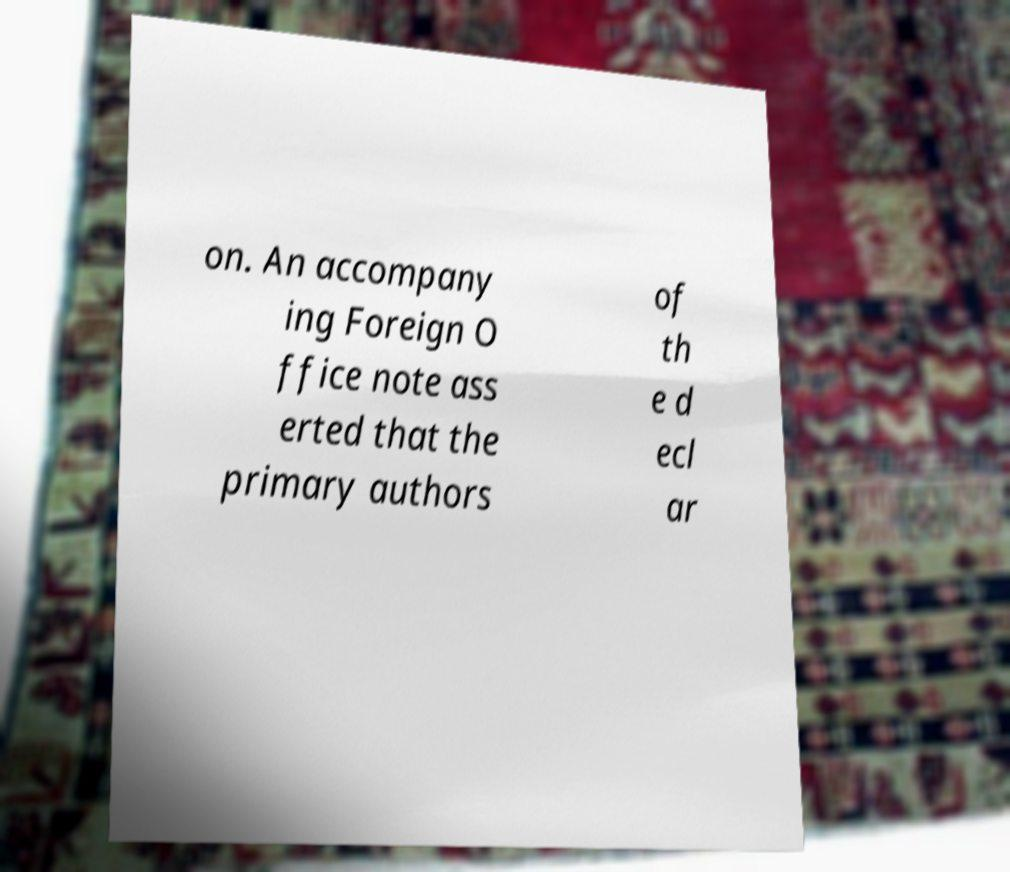Could you assist in decoding the text presented in this image and type it out clearly? on. An accompany ing Foreign O ffice note ass erted that the primary authors of th e d ecl ar 